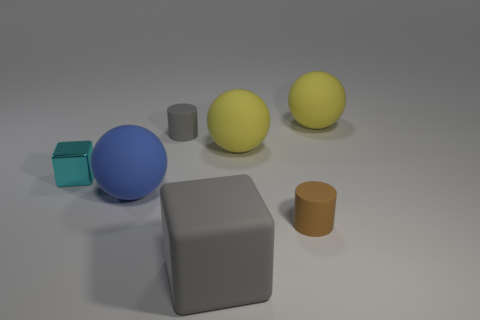Is there any other thing that has the same material as the cyan block?
Offer a very short reply. No. Are there an equal number of small shiny objects to the right of the large rubber cube and small gray cylinders?
Offer a very short reply. No. There is a rubber object that is in front of the cyan shiny object and behind the small brown thing; what is its size?
Your answer should be compact. Large. What is the color of the big thing left of the rubber cylinder that is behind the tiny cyan shiny block?
Your answer should be compact. Blue. How many cyan objects are either metallic cylinders or small things?
Your response must be concise. 1. There is a large matte object that is both on the right side of the rubber block and to the left of the brown rubber object; what is its color?
Offer a very short reply. Yellow. How many tiny things are blue matte balls or gray balls?
Provide a succinct answer. 0. There is a gray rubber object that is the same shape as the brown rubber thing; what size is it?
Provide a succinct answer. Small. The blue thing is what shape?
Your response must be concise. Sphere. Does the cyan cube have the same material as the tiny thing that is in front of the big blue rubber sphere?
Offer a very short reply. No. 